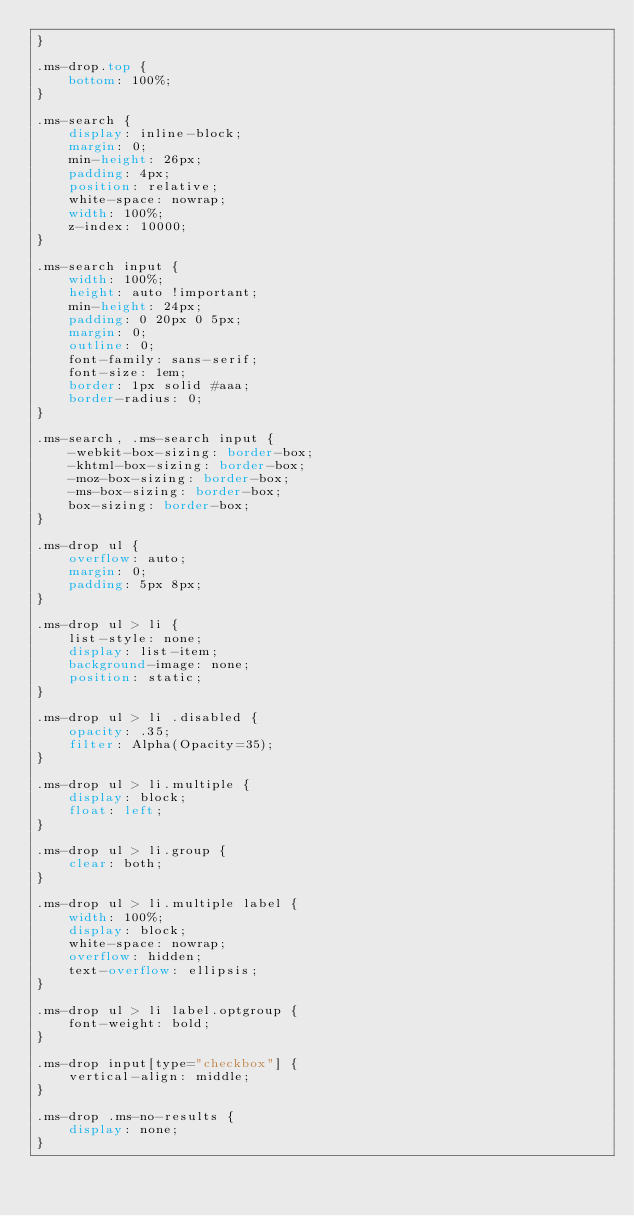Convert code to text. <code><loc_0><loc_0><loc_500><loc_500><_CSS_>}

.ms-drop.top {
    bottom: 100%;
}

.ms-search {
    display: inline-block;
    margin: 0;
    min-height: 26px;
    padding: 4px;
    position: relative;
    white-space: nowrap;
    width: 100%;
    z-index: 10000;
}

.ms-search input {
    width: 100%;
    height: auto !important;
    min-height: 24px;
    padding: 0 20px 0 5px;
    margin: 0;
    outline: 0;
    font-family: sans-serif;
    font-size: 1em;
    border: 1px solid #aaa;
    border-radius: 0;
}

.ms-search, .ms-search input {
    -webkit-box-sizing: border-box;
    -khtml-box-sizing: border-box;
    -moz-box-sizing: border-box;
    -ms-box-sizing: border-box;
    box-sizing: border-box;
}

.ms-drop ul {
    overflow: auto;
    margin: 0;
    padding: 5px 8px;
}

.ms-drop ul > li {
    list-style: none;
    display: list-item;
    background-image: none;
    position: static;
}

.ms-drop ul > li .disabled {
    opacity: .35;
    filter: Alpha(Opacity=35);
}

.ms-drop ul > li.multiple {
    display: block;
    float: left;
}

.ms-drop ul > li.group {
    clear: both;
}

.ms-drop ul > li.multiple label {
    width: 100%;
    display: block;
    white-space: nowrap;
    overflow: hidden;
    text-overflow: ellipsis;
}

.ms-drop ul > li label.optgroup {
    font-weight: bold;
}

.ms-drop input[type="checkbox"] {
    vertical-align: middle;
}

.ms-drop .ms-no-results {
    display: none;
}
</code> 